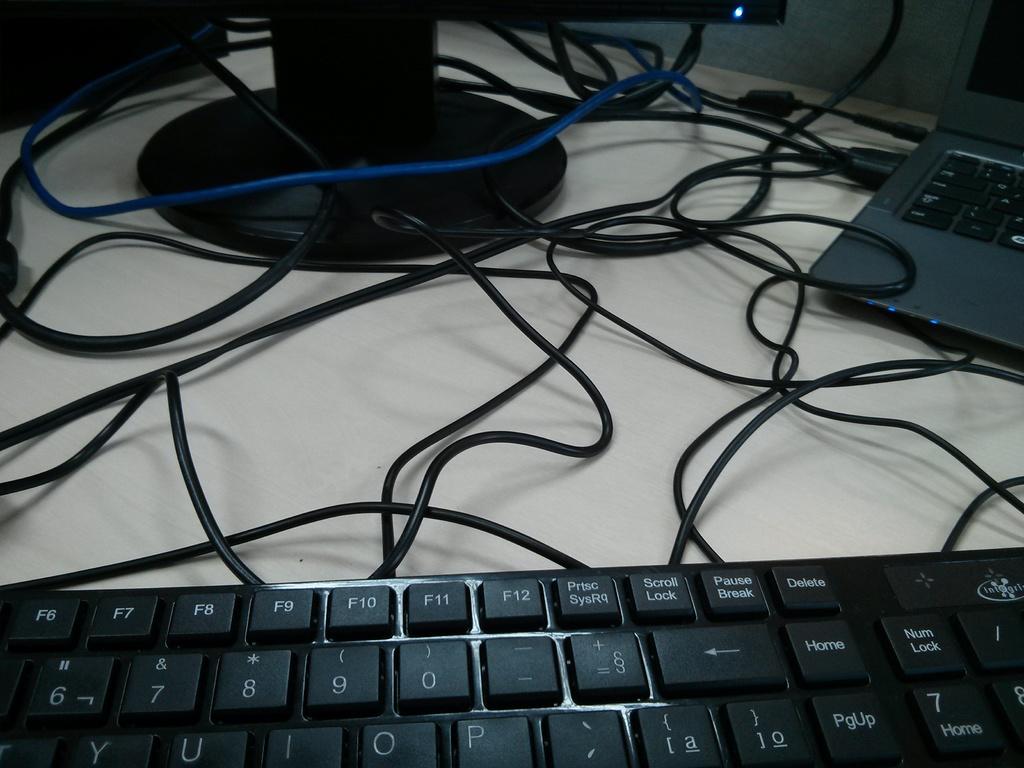What key can you see on the top left of the keyboard?
Ensure brevity in your answer.  F6. 